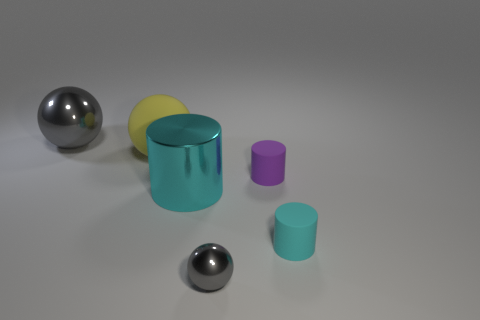There is a big thing that is the same color as the tiny sphere; what is it made of?
Ensure brevity in your answer.  Metal. What is the color of the large metallic sphere?
Offer a very short reply. Gray. Do the gray metal object on the right side of the large cyan thing and the cyan shiny thing have the same shape?
Provide a succinct answer. No. How many things are big yellow rubber spheres or gray metal things in front of the big shiny cylinder?
Offer a very short reply. 2. Are the cyan cylinder on the left side of the purple matte thing and the yellow sphere made of the same material?
Provide a succinct answer. No. Is there anything else that is the same size as the yellow rubber sphere?
Keep it short and to the point. Yes. What material is the purple cylinder that is in front of the big gray ball that is behind the tiny cyan object?
Your answer should be compact. Rubber. Are there more matte objects that are behind the tiny purple matte thing than big matte spheres on the right side of the large cyan cylinder?
Provide a short and direct response. Yes. What size is the purple thing?
Your answer should be compact. Small. Does the shiny ball on the left side of the small metallic thing have the same color as the small shiny sphere?
Your response must be concise. Yes. 